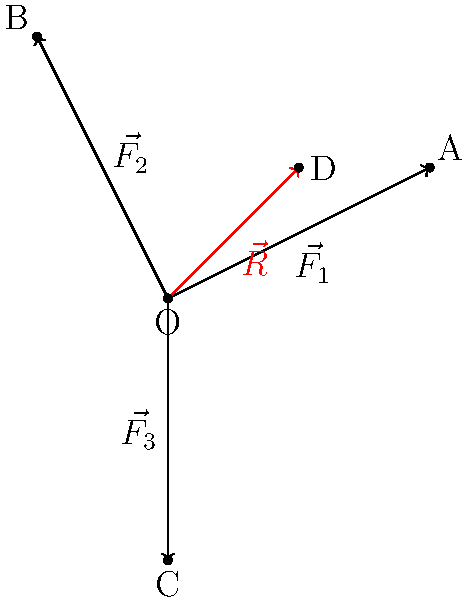A Paralympic shooter is using a specialized rifle stand that experiences three forces: $\vec{F_1} = 2\hat{i} + \hat{j}$, $\vec{F_2} = -\hat{i} + 2\hat{j}$, and $\vec{F_3} = -2\hat{j}$ (all in Newtons). What is the magnitude of the resultant force $\vec{R}$ acting on the stand? To find the magnitude of the resultant force, we need to follow these steps:

1) First, we add the three force vectors:
   $\vec{R} = \vec{F_1} + \vec{F_2} + \vec{F_3}$

2) Let's add the components:
   $\vec{R} = (2\hat{i} + \hat{j}) + (-\hat{i} + 2\hat{j}) + (-2\hat{j})$
   $\vec{R} = (2-1)\hat{i} + (1+2-2)\hat{j}$
   $\vec{R} = \hat{i} + \hat{j}$

3) Now that we have the resultant vector, we can calculate its magnitude using the Pythagorean theorem:
   $|\vec{R}| = \sqrt{(1)^2 + (1)^2}$

4) Simplify:
   $|\vec{R}| = \sqrt{1 + 1} = \sqrt{2}$

Therefore, the magnitude of the resultant force is $\sqrt{2}$ Newtons.
Answer: $\sqrt{2}$ N 